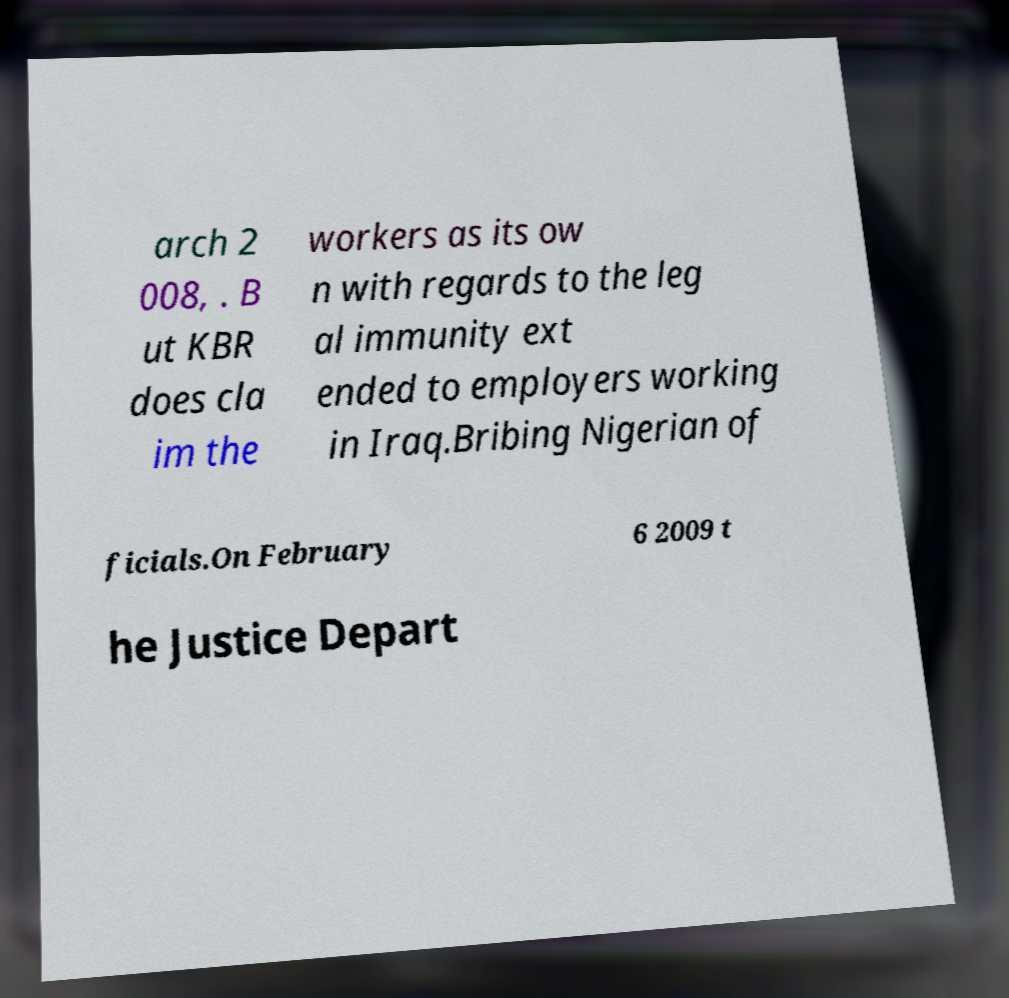For documentation purposes, I need the text within this image transcribed. Could you provide that? arch 2 008, . B ut KBR does cla im the workers as its ow n with regards to the leg al immunity ext ended to employers working in Iraq.Bribing Nigerian of ficials.On February 6 2009 t he Justice Depart 